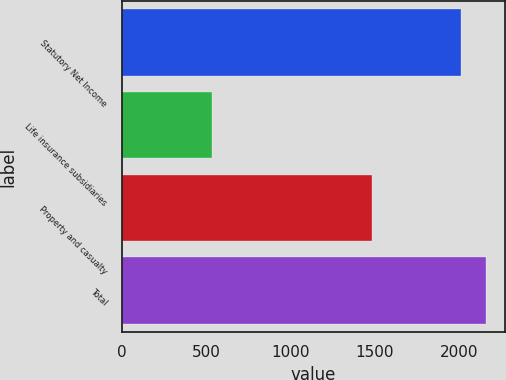Convert chart to OTSL. <chart><loc_0><loc_0><loc_500><loc_500><bar_chart><fcel>Statutory Net Income<fcel>Life insurance subsidiaries<fcel>Property and casualty<fcel>Total<nl><fcel>2015<fcel>539<fcel>1486<fcel>2163.6<nl></chart> 